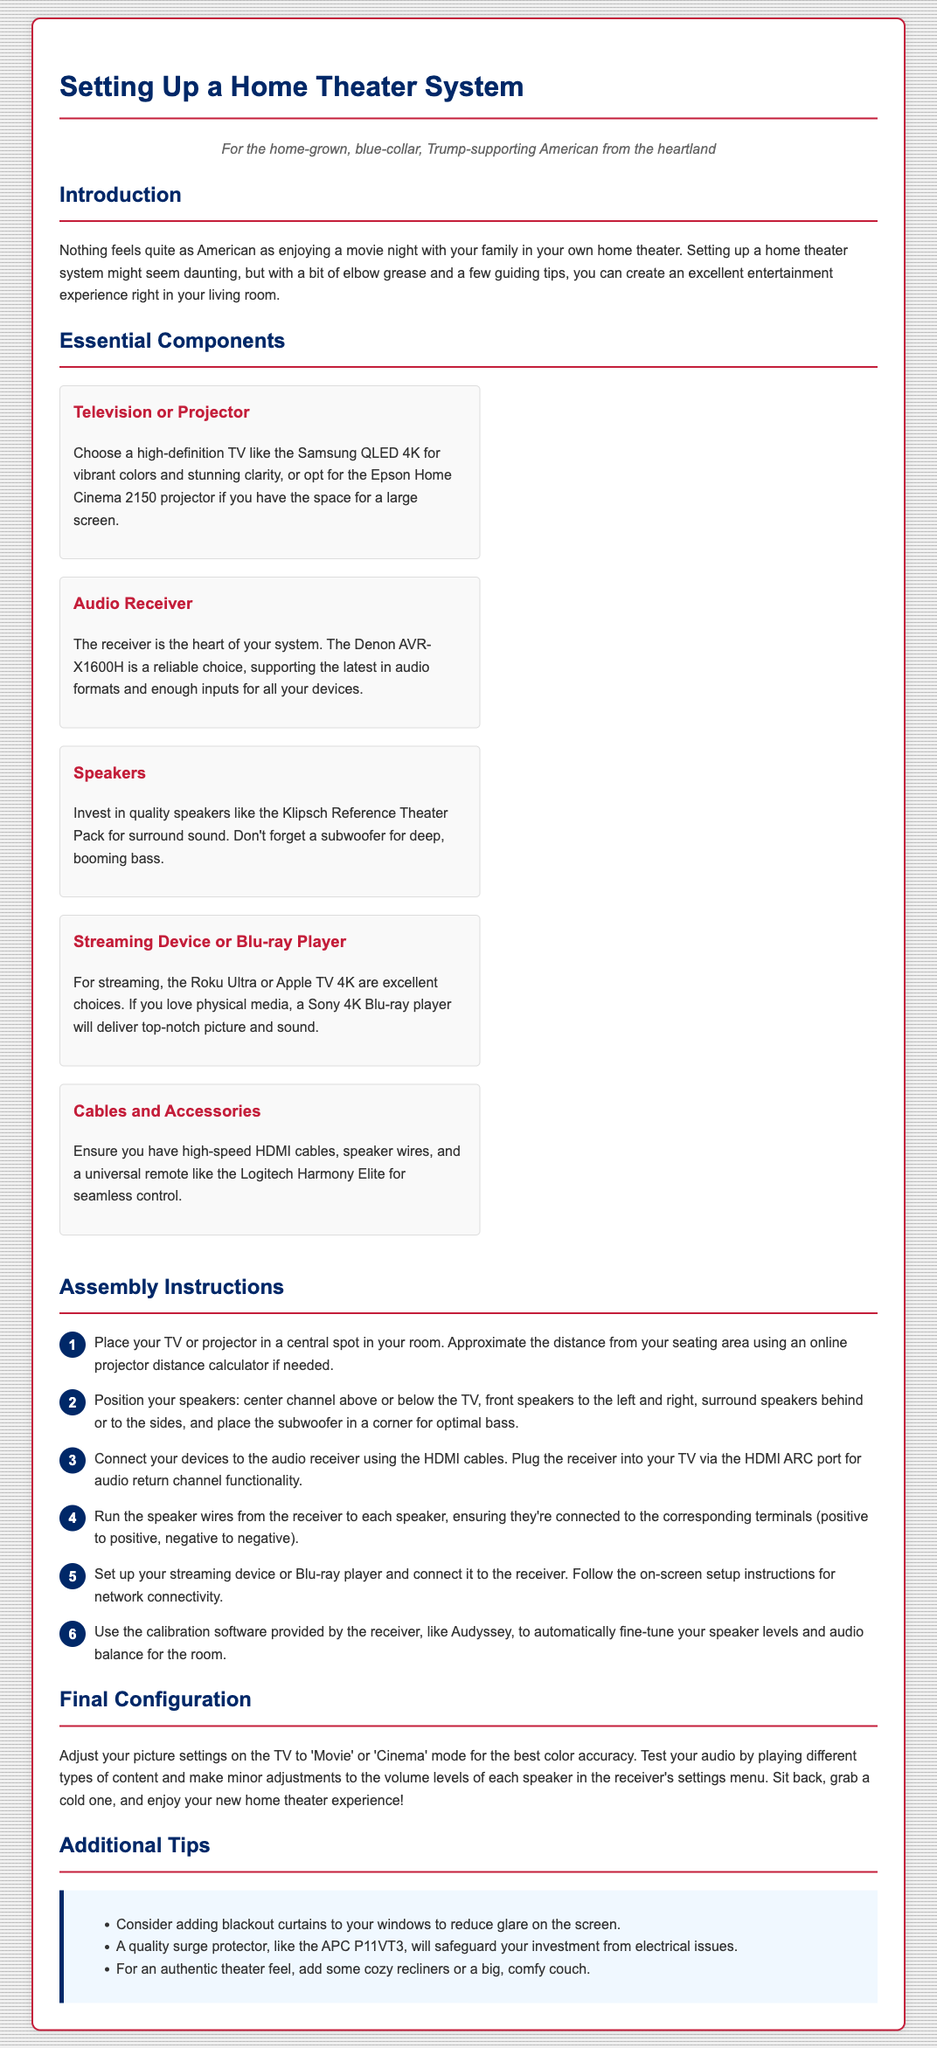What is the purpose of the guide? The guide is about setting up a home theater system for an excellent entertainment experience.
Answer: setting up a home theater system What speaker brand is recommended for surround sound? The document mentions a specific brand that is known for its surround sound quality.
Answer: Klipsch What is the model of the recommended audio receiver? The document specifies a reliable audio receiver model ideal for the home theater system.
Answer: Denon AVR-X1600H How many assembly steps are provided in the document? The document lists the assembly instructions in an ordered list format.
Answer: six What should you adjust the TV picture settings to for the best color accuracy? The document provides a specific mode for optimal picture quality settings.
Answer: Movie or Cinema What type of device is the Roku Ultra classified as? The document categorizes the Roku Ultra based on its function in the home theater.
Answer: Streaming device What should be used to connect the receiver to the TV? The document specifies a type of cable necessary for this connection.
Answer: HDMI cable Where should the subwoofer be placed for optimal bass? The document gives a specific location for ideal bass enhancement.
Answer: in a corner What additional feature does the HDMI ARC port provide? The document mentions the function provided by the HDMI ARC connection.
Answer: audio return channel functionality 